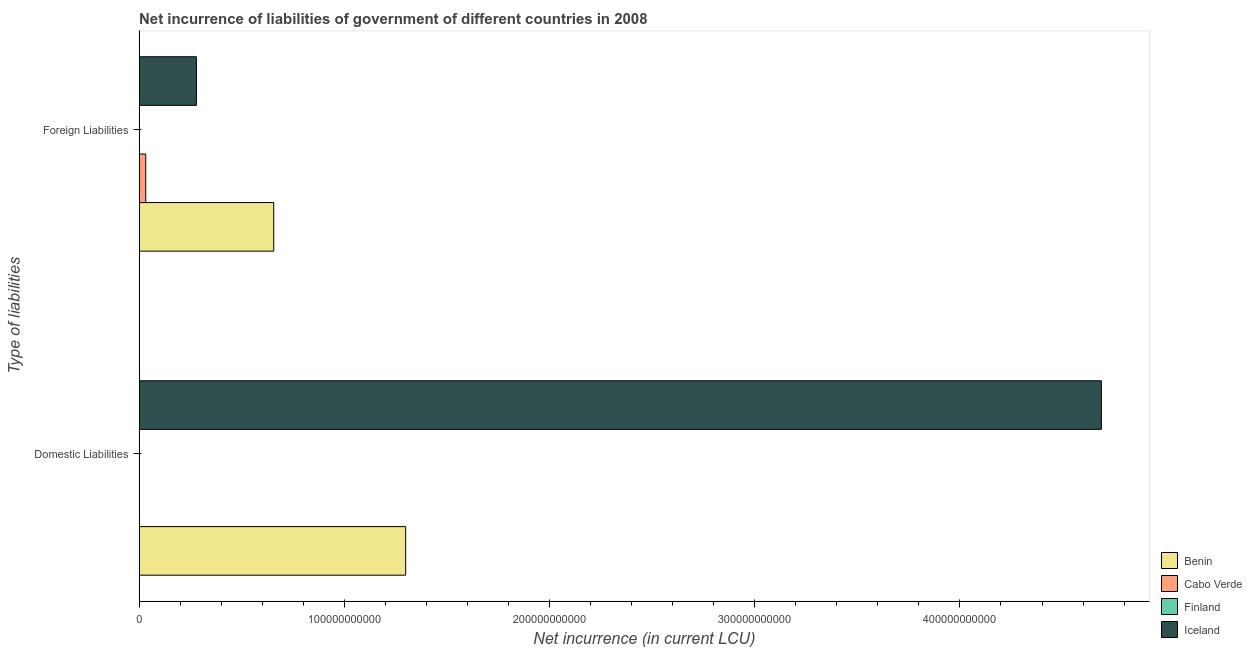How many different coloured bars are there?
Offer a very short reply. 3. Are the number of bars per tick equal to the number of legend labels?
Make the answer very short. No. Are the number of bars on each tick of the Y-axis equal?
Provide a succinct answer. No. How many bars are there on the 1st tick from the bottom?
Offer a terse response. 2. What is the label of the 1st group of bars from the top?
Your response must be concise. Foreign Liabilities. What is the net incurrence of foreign liabilities in Finland?
Your answer should be very brief. 0. Across all countries, what is the maximum net incurrence of domestic liabilities?
Give a very brief answer. 4.69e+11. In which country was the net incurrence of foreign liabilities maximum?
Make the answer very short. Benin. What is the total net incurrence of domestic liabilities in the graph?
Provide a succinct answer. 5.99e+11. What is the difference between the net incurrence of foreign liabilities in Cabo Verde and that in Benin?
Your answer should be very brief. -6.24e+1. What is the difference between the net incurrence of domestic liabilities in Benin and the net incurrence of foreign liabilities in Cabo Verde?
Provide a short and direct response. 1.27e+11. What is the average net incurrence of domestic liabilities per country?
Provide a short and direct response. 1.50e+11. What is the difference between the net incurrence of domestic liabilities and net incurrence of foreign liabilities in Iceland?
Give a very brief answer. 4.41e+11. What is the ratio of the net incurrence of foreign liabilities in Benin to that in Iceland?
Your response must be concise. 2.35. How many bars are there?
Provide a short and direct response. 5. Are all the bars in the graph horizontal?
Provide a short and direct response. Yes. How many countries are there in the graph?
Give a very brief answer. 4. What is the difference between two consecutive major ticks on the X-axis?
Offer a terse response. 1.00e+11. Does the graph contain any zero values?
Keep it short and to the point. Yes. How many legend labels are there?
Keep it short and to the point. 4. How are the legend labels stacked?
Offer a terse response. Vertical. What is the title of the graph?
Your response must be concise. Net incurrence of liabilities of government of different countries in 2008. What is the label or title of the X-axis?
Provide a succinct answer. Net incurrence (in current LCU). What is the label or title of the Y-axis?
Ensure brevity in your answer.  Type of liabilities. What is the Net incurrence (in current LCU) of Benin in Domestic Liabilities?
Your response must be concise. 1.30e+11. What is the Net incurrence (in current LCU) in Cabo Verde in Domestic Liabilities?
Offer a very short reply. 0. What is the Net incurrence (in current LCU) in Finland in Domestic Liabilities?
Offer a very short reply. 0. What is the Net incurrence (in current LCU) in Iceland in Domestic Liabilities?
Make the answer very short. 4.69e+11. What is the Net incurrence (in current LCU) of Benin in Foreign Liabilities?
Your response must be concise. 6.56e+1. What is the Net incurrence (in current LCU) of Cabo Verde in Foreign Liabilities?
Keep it short and to the point. 3.25e+09. What is the Net incurrence (in current LCU) in Iceland in Foreign Liabilities?
Ensure brevity in your answer.  2.79e+1. Across all Type of liabilities, what is the maximum Net incurrence (in current LCU) of Benin?
Make the answer very short. 1.30e+11. Across all Type of liabilities, what is the maximum Net incurrence (in current LCU) in Cabo Verde?
Offer a terse response. 3.25e+09. Across all Type of liabilities, what is the maximum Net incurrence (in current LCU) in Iceland?
Your answer should be very brief. 4.69e+11. Across all Type of liabilities, what is the minimum Net incurrence (in current LCU) in Benin?
Offer a terse response. 6.56e+1. Across all Type of liabilities, what is the minimum Net incurrence (in current LCU) in Iceland?
Your answer should be very brief. 2.79e+1. What is the total Net incurrence (in current LCU) of Benin in the graph?
Offer a terse response. 1.96e+11. What is the total Net incurrence (in current LCU) of Cabo Verde in the graph?
Ensure brevity in your answer.  3.25e+09. What is the total Net incurrence (in current LCU) of Finland in the graph?
Offer a terse response. 0. What is the total Net incurrence (in current LCU) of Iceland in the graph?
Ensure brevity in your answer.  4.97e+11. What is the difference between the Net incurrence (in current LCU) of Benin in Domestic Liabilities and that in Foreign Liabilities?
Your answer should be very brief. 6.43e+1. What is the difference between the Net incurrence (in current LCU) in Iceland in Domestic Liabilities and that in Foreign Liabilities?
Give a very brief answer. 4.41e+11. What is the difference between the Net incurrence (in current LCU) in Benin in Domestic Liabilities and the Net incurrence (in current LCU) in Cabo Verde in Foreign Liabilities?
Your answer should be very brief. 1.27e+11. What is the difference between the Net incurrence (in current LCU) of Benin in Domestic Liabilities and the Net incurrence (in current LCU) of Iceland in Foreign Liabilities?
Offer a terse response. 1.02e+11. What is the average Net incurrence (in current LCU) of Benin per Type of liabilities?
Offer a very short reply. 9.78e+1. What is the average Net incurrence (in current LCU) of Cabo Verde per Type of liabilities?
Ensure brevity in your answer.  1.62e+09. What is the average Net incurrence (in current LCU) in Iceland per Type of liabilities?
Your answer should be compact. 2.48e+11. What is the difference between the Net incurrence (in current LCU) of Benin and Net incurrence (in current LCU) of Iceland in Domestic Liabilities?
Make the answer very short. -3.39e+11. What is the difference between the Net incurrence (in current LCU) of Benin and Net incurrence (in current LCU) of Cabo Verde in Foreign Liabilities?
Provide a short and direct response. 6.24e+1. What is the difference between the Net incurrence (in current LCU) in Benin and Net incurrence (in current LCU) in Iceland in Foreign Liabilities?
Make the answer very short. 3.77e+1. What is the difference between the Net incurrence (in current LCU) of Cabo Verde and Net incurrence (in current LCU) of Iceland in Foreign Liabilities?
Your answer should be very brief. -2.47e+1. What is the ratio of the Net incurrence (in current LCU) of Benin in Domestic Liabilities to that in Foreign Liabilities?
Your response must be concise. 1.98. What is the ratio of the Net incurrence (in current LCU) of Iceland in Domestic Liabilities to that in Foreign Liabilities?
Make the answer very short. 16.8. What is the difference between the highest and the second highest Net incurrence (in current LCU) in Benin?
Keep it short and to the point. 6.43e+1. What is the difference between the highest and the second highest Net incurrence (in current LCU) of Iceland?
Provide a short and direct response. 4.41e+11. What is the difference between the highest and the lowest Net incurrence (in current LCU) of Benin?
Ensure brevity in your answer.  6.43e+1. What is the difference between the highest and the lowest Net incurrence (in current LCU) in Cabo Verde?
Offer a very short reply. 3.25e+09. What is the difference between the highest and the lowest Net incurrence (in current LCU) of Iceland?
Make the answer very short. 4.41e+11. 